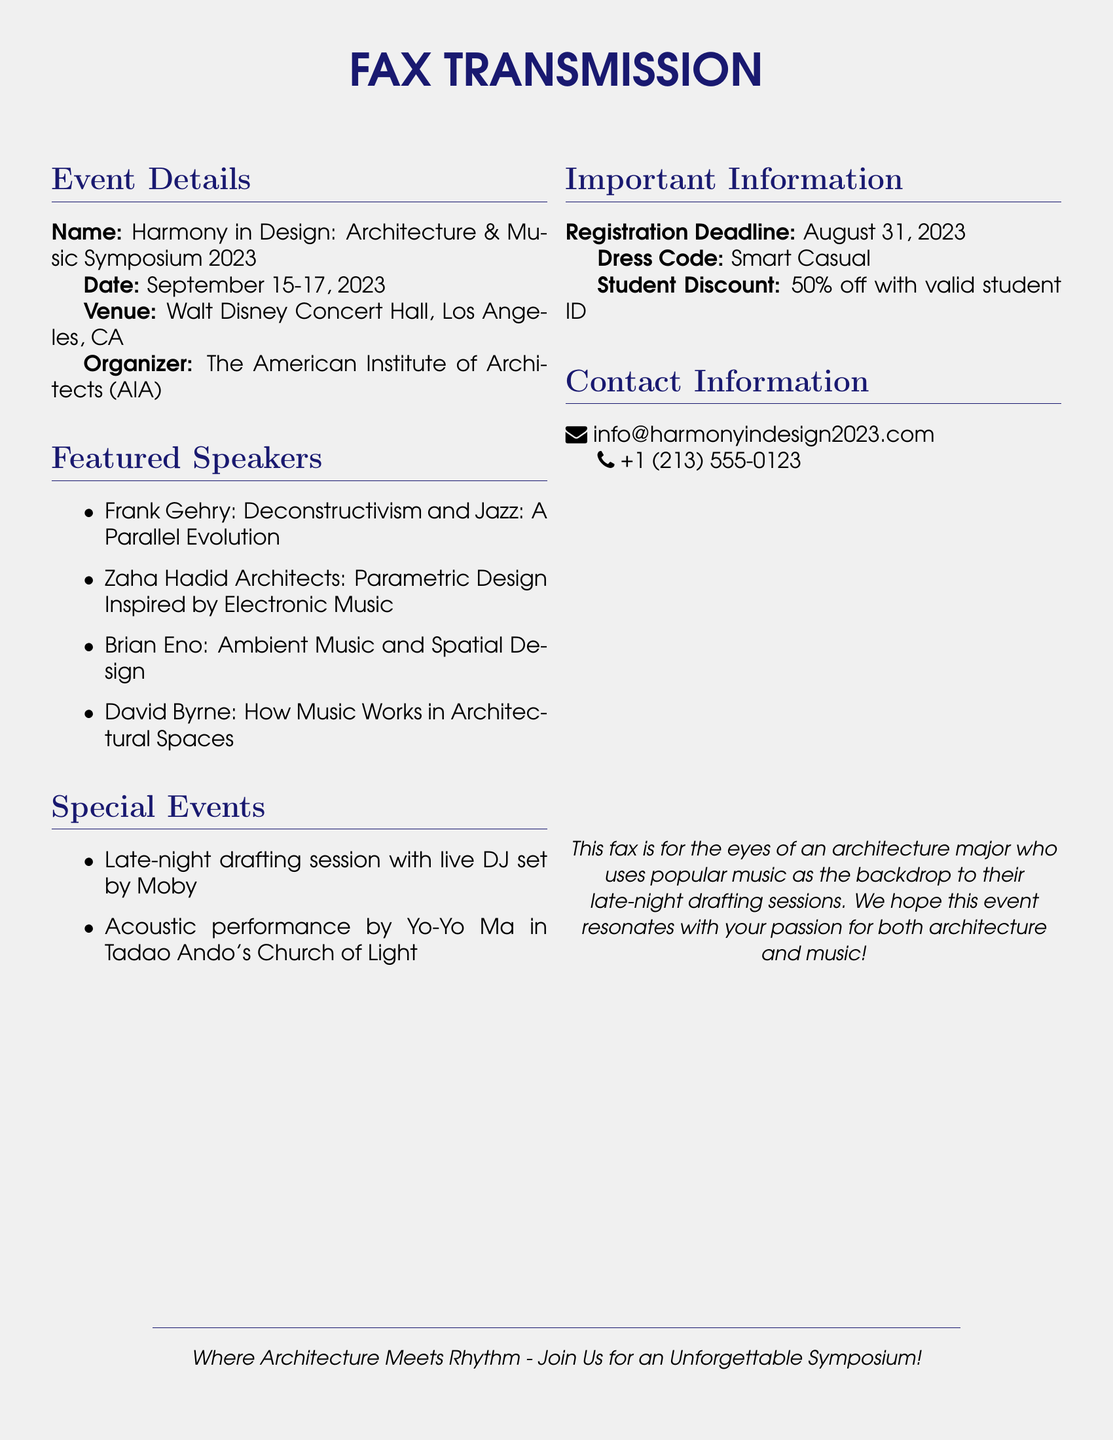What is the name of the symposium? The name is mentioned under Event Details, which is "Harmony in Design: Architecture & Music Symposium 2023."
Answer: Harmony in Design: Architecture & Music Symposium 2023 When is the registration deadline? The registration deadline is specified under Important Information as August 31, 2023.
Answer: August 31, 2023 Where is the event taking place? The venue for the event is listed under Event Details as Walt Disney Concert Hall, Los Angeles, CA.
Answer: Walt Disney Concert Hall, Los Angeles, CA Who is performing an acoustic set at the event? The acoustic performance is mentioned under Special Events, with Yo-Yo Ma as the performer.
Answer: Yo-Yo Ma What percentage off do students receive on registration? The student discount is stated under Important Information, given as 50% off.
Answer: 50% What type of event features a live DJ set? The late-night drafting session is indicated under Special Events as having a live DJ set by Moby.
Answer: Late-night drafting session Who is the organizer of the symposium? The organizer is mentioned under Event Details as The American Institute of Architects (AIA).
Answer: The American Institute of Architects (AIA) What is the dress code for the event? The dress code is specified under Important Information as Smart Casual.
Answer: Smart Casual 